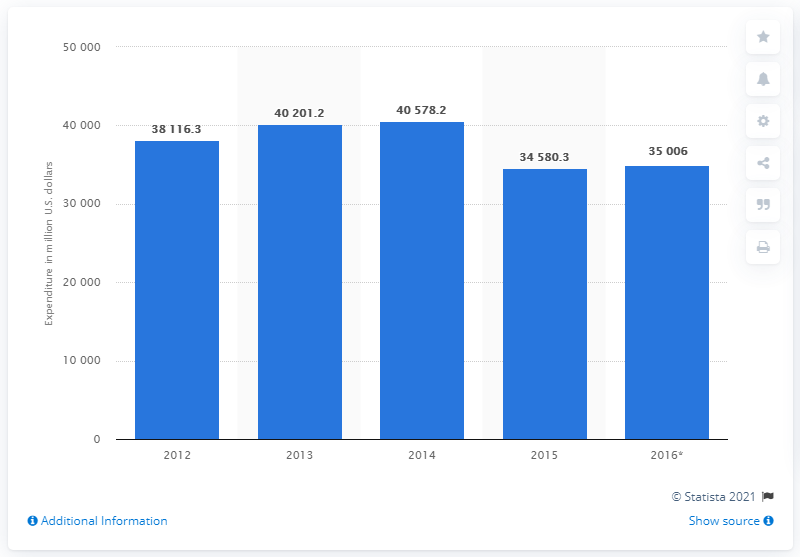Indicate a few pertinent items in this graphic. The estimated expenditure on food in the United States for the year 2016 is expected to reach approximately 35,006 million dollars. 